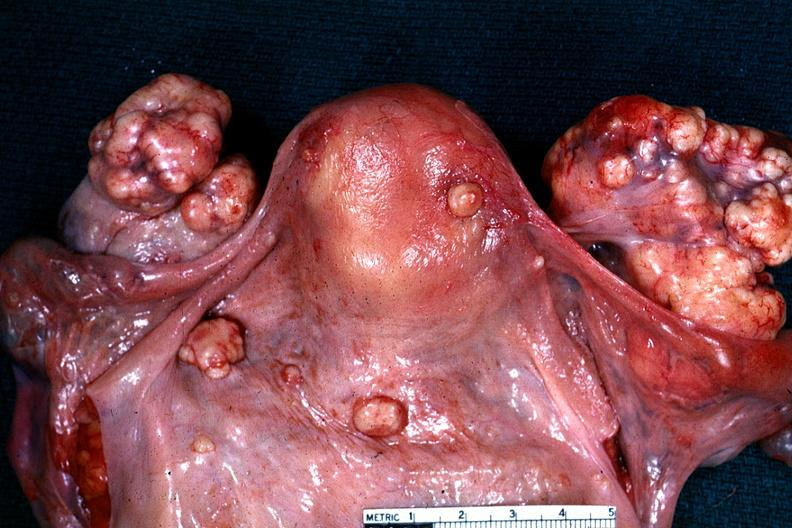s female reproductive present?
Answer the question using a single word or phrase. Yes 